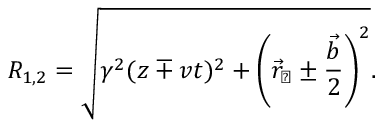Convert formula to latex. <formula><loc_0><loc_0><loc_500><loc_500>R _ { 1 , 2 } = \sqrt { \gamma ^ { 2 } ( z \mp v t ) ^ { 2 } + \left ( \vec { r } _ { \perp } \pm { \frac { \vec { b } } { 2 } } \right ) ^ { 2 } } .</formula> 